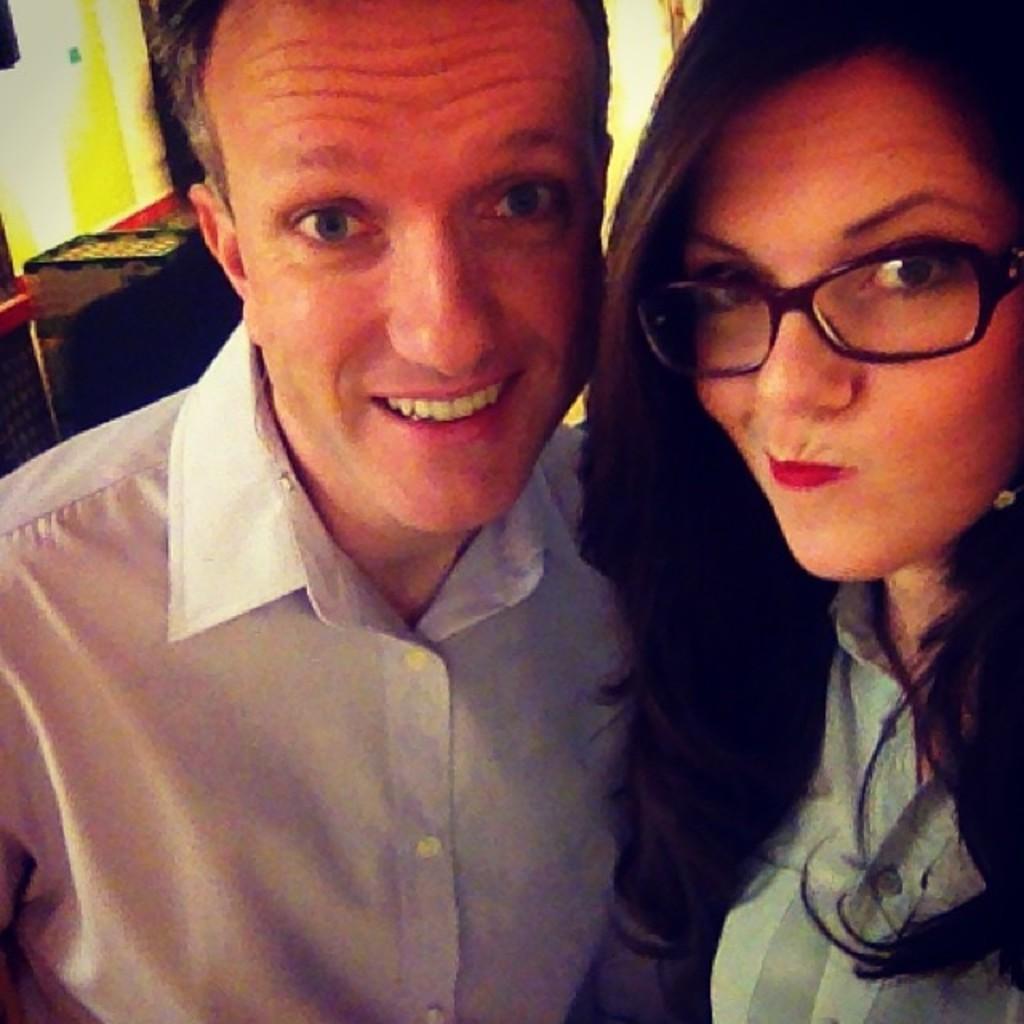Please provide a concise description of this image. Here we can see a man and a woman. In the background we can see a person,wall and other objects. 